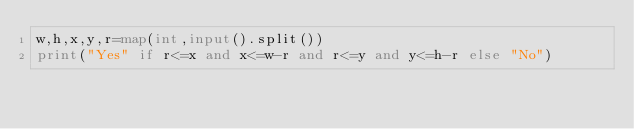Convert code to text. <code><loc_0><loc_0><loc_500><loc_500><_Python_>w,h,x,y,r=map(int,input().split())
print("Yes" if r<=x and x<=w-r and r<=y and y<=h-r else "No")

</code> 